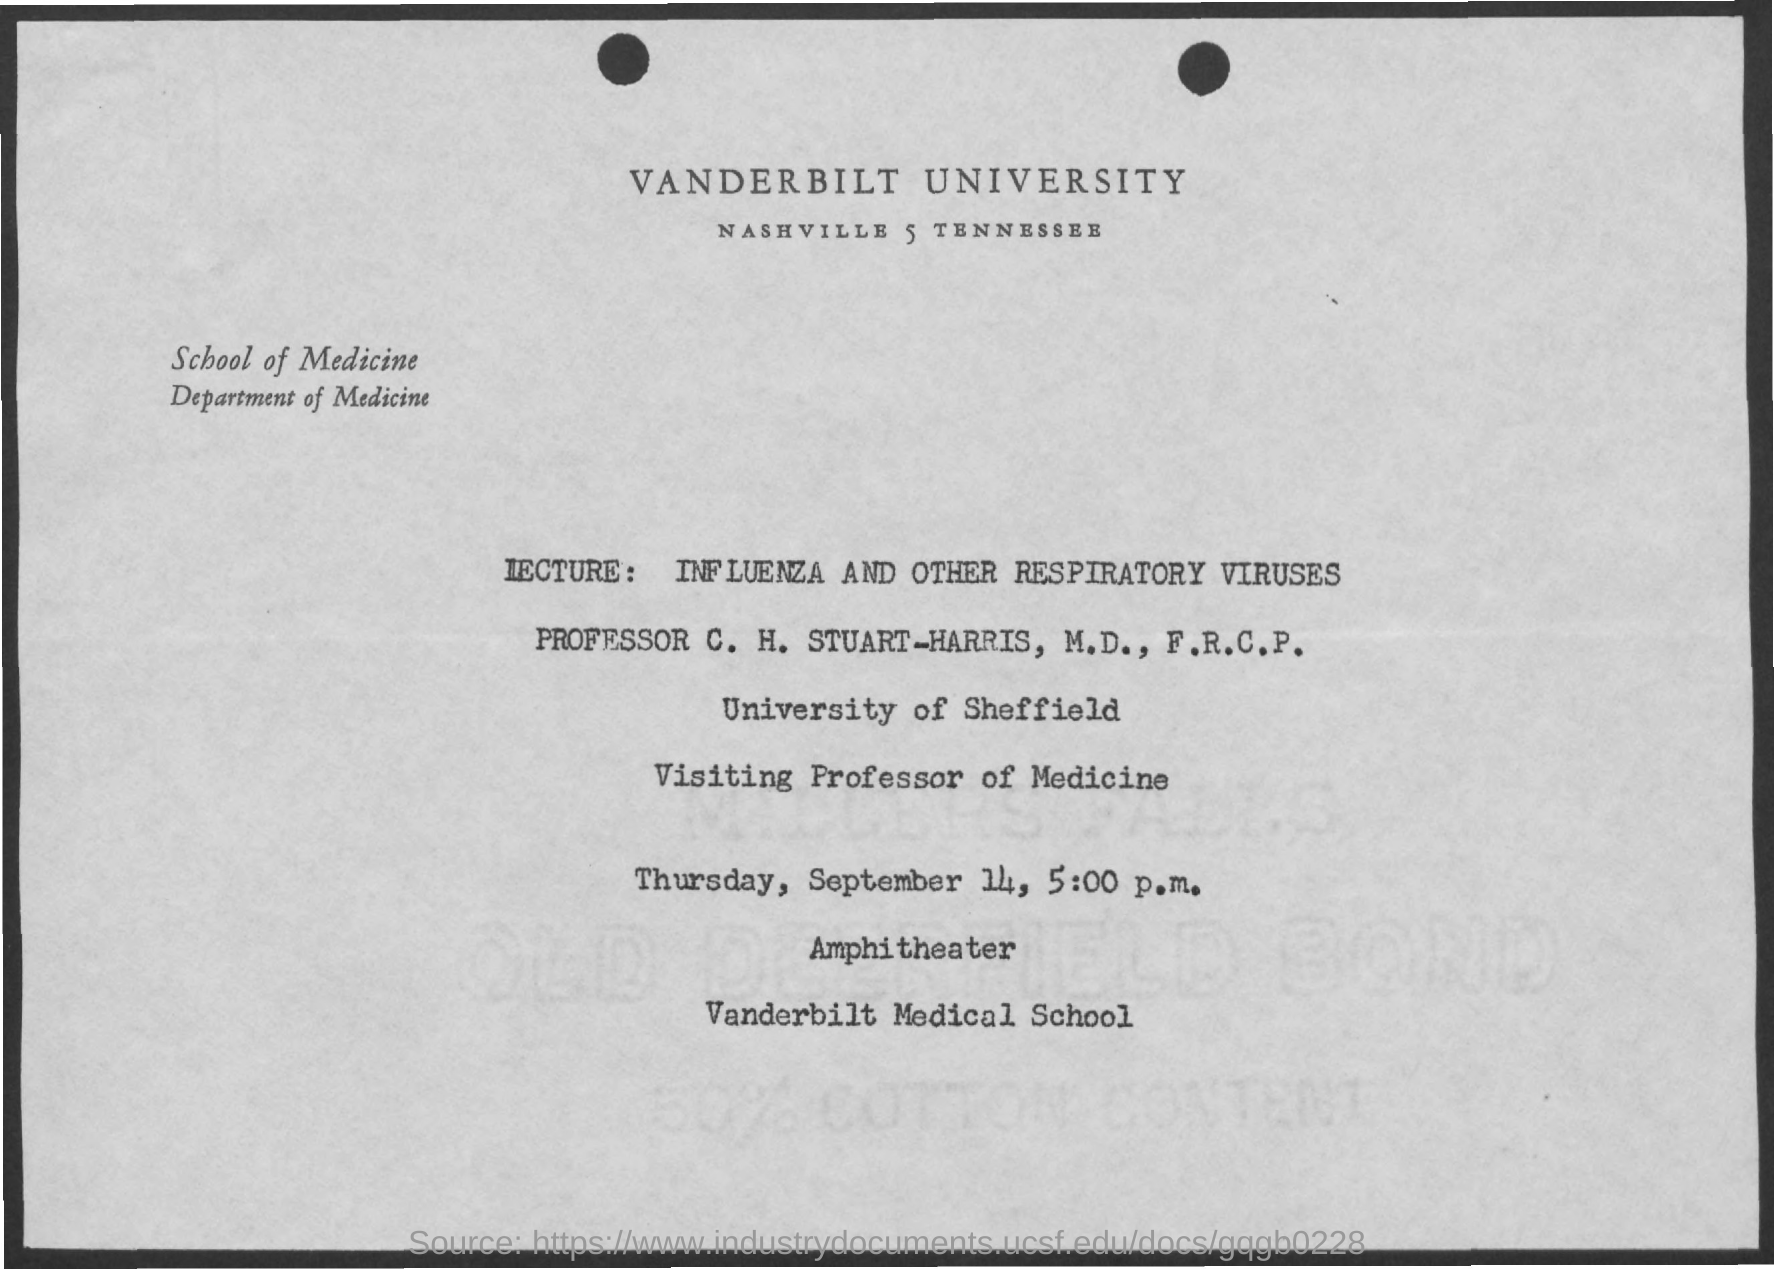What is the name of the department mentioned in the given form ?
Give a very brief answer. Department of medicine. What is the lecture mentioned ?
Your answer should be compact. Influenza and other respiratory viruses. What is the date mentioned in the given page ?
Offer a terse response. September 14. What is the time mentioned ?
Your answer should be compact. 5:00 p.m. 